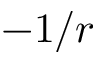<formula> <loc_0><loc_0><loc_500><loc_500>- 1 / r</formula> 